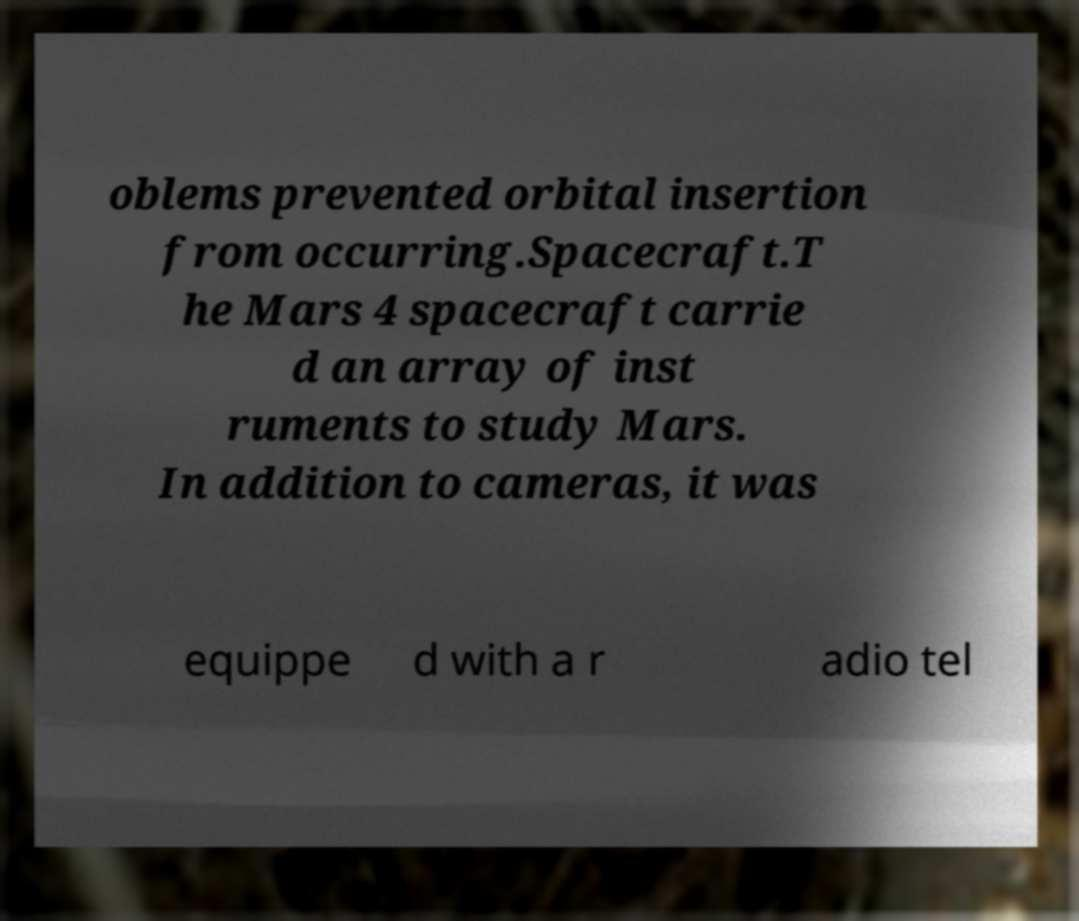Could you extract and type out the text from this image? oblems prevented orbital insertion from occurring.Spacecraft.T he Mars 4 spacecraft carrie d an array of inst ruments to study Mars. In addition to cameras, it was equippe d with a r adio tel 